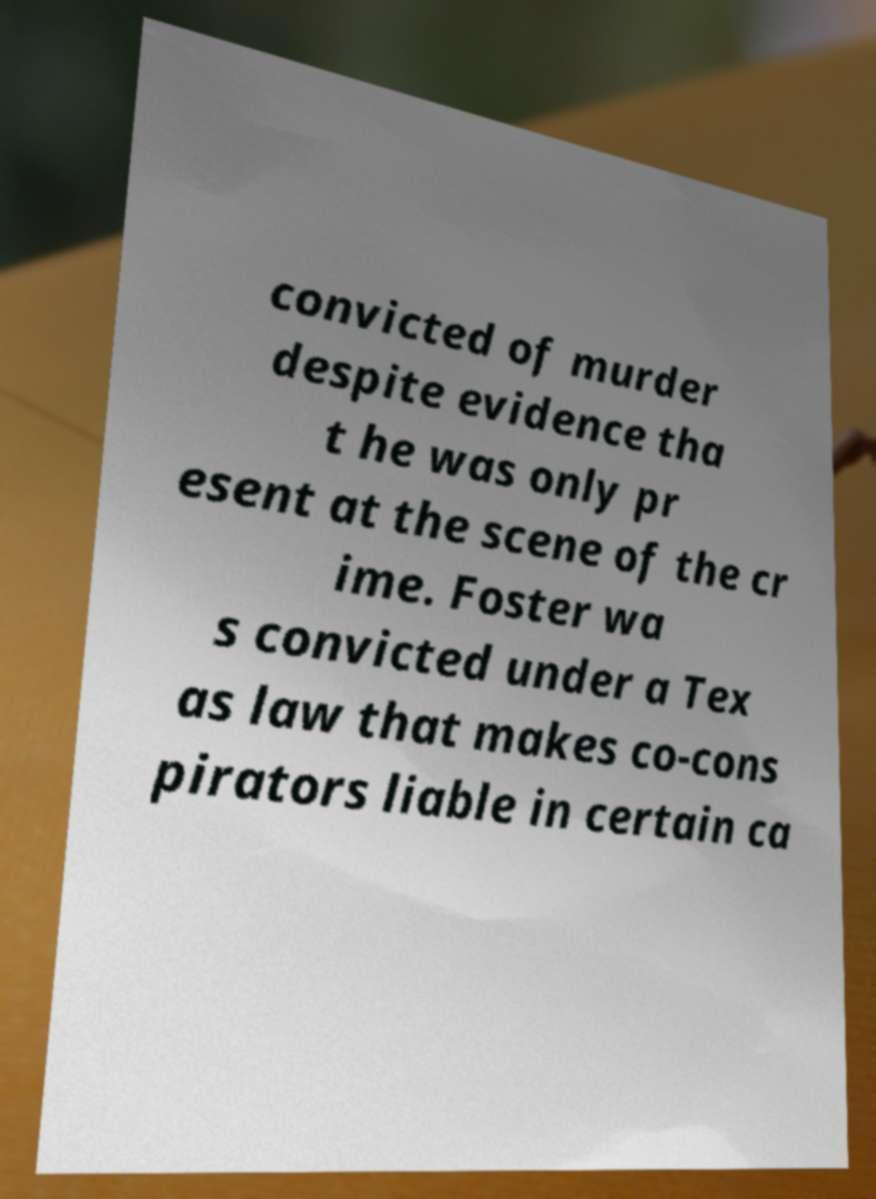Please identify and transcribe the text found in this image. convicted of murder despite evidence tha t he was only pr esent at the scene of the cr ime. Foster wa s convicted under a Tex as law that makes co-cons pirators liable in certain ca 